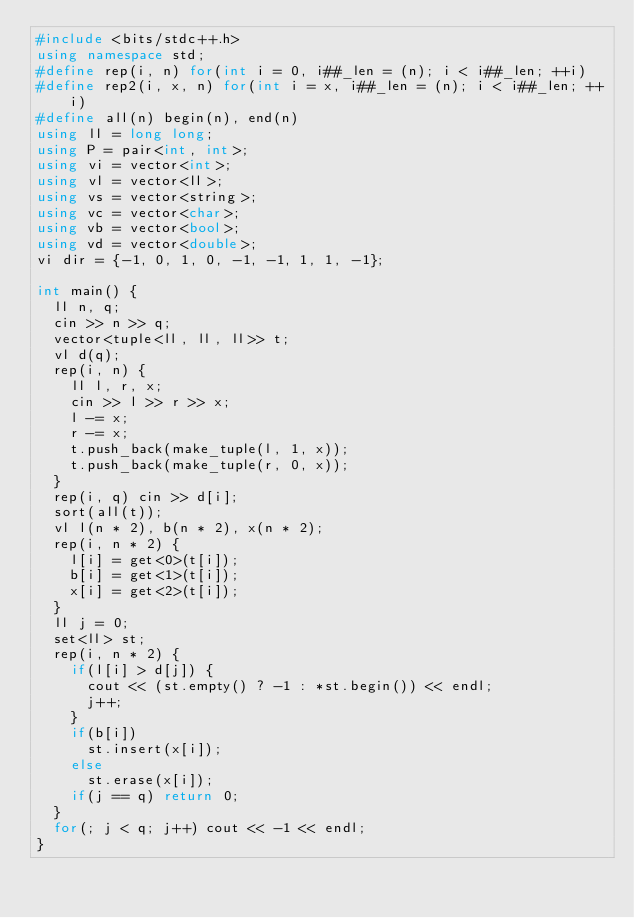<code> <loc_0><loc_0><loc_500><loc_500><_C++_>#include <bits/stdc++.h>
using namespace std;
#define rep(i, n) for(int i = 0, i##_len = (n); i < i##_len; ++i)
#define rep2(i, x, n) for(int i = x, i##_len = (n); i < i##_len; ++i)
#define all(n) begin(n), end(n)
using ll = long long;
using P = pair<int, int>;
using vi = vector<int>;
using vl = vector<ll>;
using vs = vector<string>;
using vc = vector<char>;
using vb = vector<bool>;
using vd = vector<double>;
vi dir = {-1, 0, 1, 0, -1, -1, 1, 1, -1};

int main() {
  ll n, q;
  cin >> n >> q;
  vector<tuple<ll, ll, ll>> t;
  vl d(q);
  rep(i, n) {
    ll l, r, x;
    cin >> l >> r >> x;
    l -= x;
    r -= x;
    t.push_back(make_tuple(l, 1, x));
    t.push_back(make_tuple(r, 0, x));
  }
  rep(i, q) cin >> d[i];
  sort(all(t));
  vl l(n * 2), b(n * 2), x(n * 2);
  rep(i, n * 2) {
    l[i] = get<0>(t[i]);
    b[i] = get<1>(t[i]);
    x[i] = get<2>(t[i]);
  }
  ll j = 0;
  set<ll> st;
  rep(i, n * 2) {
    if(l[i] > d[j]) {
      cout << (st.empty() ? -1 : *st.begin()) << endl;
      j++;
    }
    if(b[i])
      st.insert(x[i]);
    else
      st.erase(x[i]);
    if(j == q) return 0;
  }
  for(; j < q; j++) cout << -1 << endl;
}</code> 